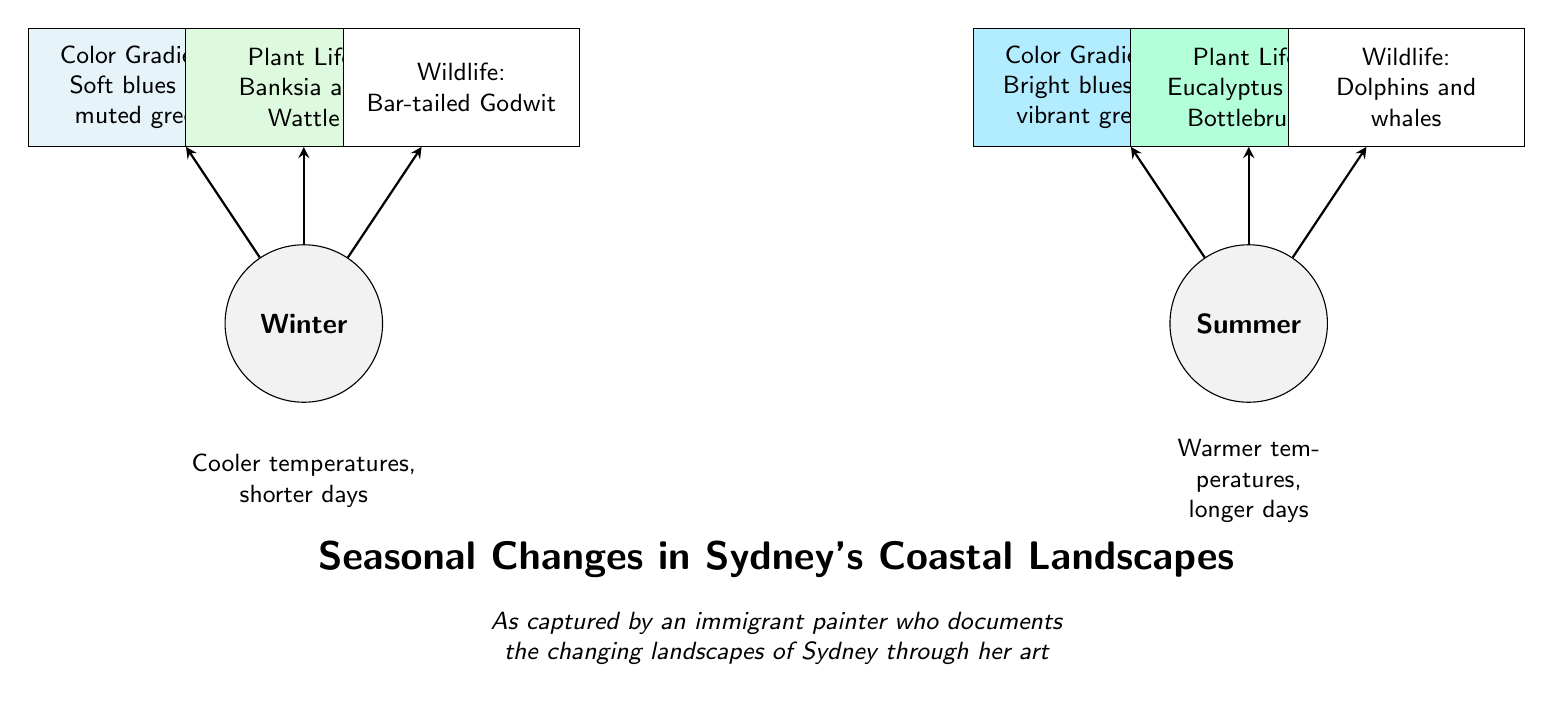What are the two seasons depicted in the diagram? The diagram distinctly shows two seasons at the top: Winter and Summer. These are visually represented as separate nodes labeled accordingly.
Answer: Winter, Summer What colors are associated with winter's color gradients? The diagram describes the color gradients for winter as "Soft blues and muted greens," stated in the color aspect connected to the winter node.
Answer: Soft blues and muted greens What type of wildlife is shown in summer? The wildlife aspect for summer indicates "Dolphins and whales", which are specified near the summer node in the diagram.
Answer: Dolphins and whales Which plant life is indicated for winter? The winter season outlines the plant life as "Banksia and Wattle," which are directly labeled in the corresponding aspect node for winter.
Answer: Banksia and Wattle How many aspects are listed under each season? The diagram lists three aspects under each season: color gradients, plant life, and wildlife, indicating a total of 3 aspects for both winter and summer.
Answer: 3 What is the description given for summer temperatures? Under the summer node, the description provides "Warmer temperatures, longer days," explicitly representing the seasonal characteristics during summer.
Answer: Warmer temperatures, longer days Which color gradients are associated with summer? The summer aspect states the color gradients are "Bright blues and vibrant greens," highlighting the vivid colors present in summer's coastal landscapes.
Answer: Bright blues and vibrant greens What plant life is shown for summer? According to the summer node, the plant life includes "Eucalyptus and Bottlebrush," which detail the types of plants present in the coastal landscape during this season.
Answer: Eucalyptus and Bottlebrush 